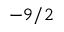<formula> <loc_0><loc_0><loc_500><loc_500>- 9 / 2</formula> 